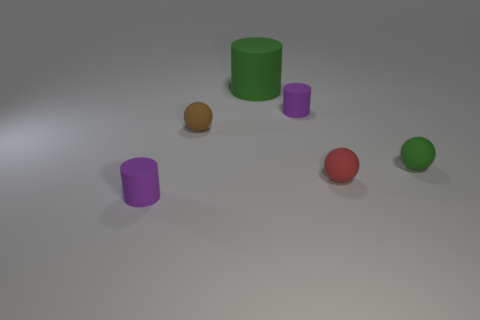What lighting conditions are present in the image? The image seems to be lit by a diffused light source, as indicated by the soft shadows cast by the objects. There's no harsh lighting or deep shadows, which implies an even and gentle illumination, possibly resembling an overcast day or soft box lighting in a studio. 